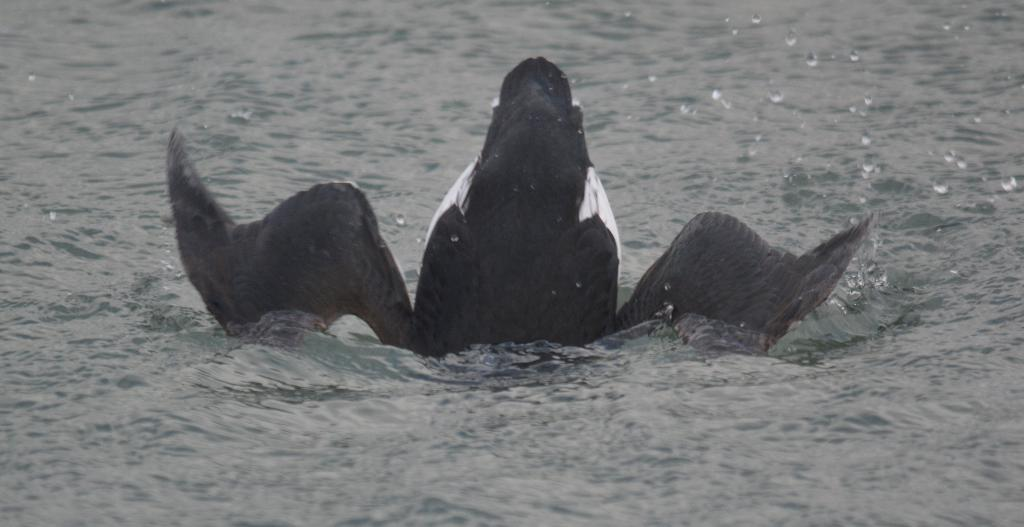What type of animal is in the image? There is a bird in the image. Where is the bird located in the image? The bird is in water. What type of beef is being served in the image? There is no beef present in the image; it features a bird in water. How does the bird provide an answer in the image? The bird does not provide an answer in the image; it is simply depicted in water. 